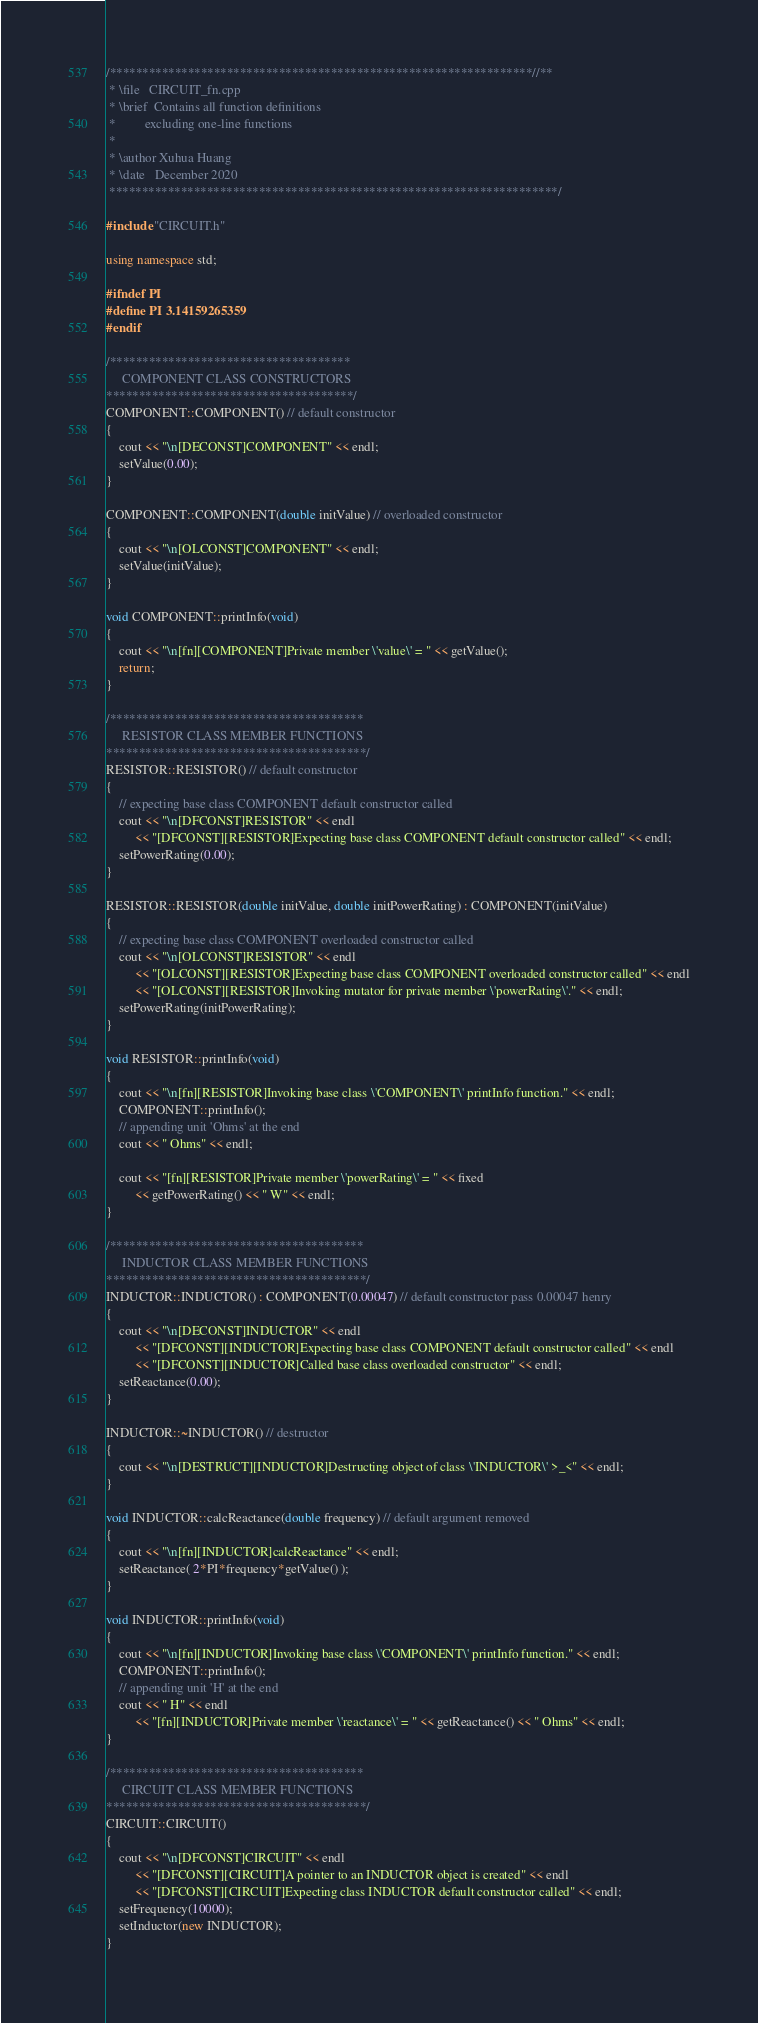<code> <loc_0><loc_0><loc_500><loc_500><_C++_>/*****************************************************************//**
 * \file   CIRCUIT_fn.cpp
 * \brief  Contains all function definitions 
 *		   excluding one-line functions
 * 
 * \author Xuhua Huang
 * \date   December 2020
 *********************************************************************/

#include "CIRCUIT.h"

using namespace std;

#ifndef PI
#define PI 3.14159265359
#endif

/*************************************
	 COMPONENT CLASS CONSTRUCTORS
**************************************/
COMPONENT::COMPONENT() // default constructor
{
	cout << "\n[DECONST]COMPONENT" << endl;
	setValue(0.00);
}

COMPONENT::COMPONENT(double initValue) // overloaded constructor
{
	cout << "\n[OLCONST]COMPONENT" << endl;
	setValue(initValue);
}

void COMPONENT::printInfo(void)
{
	cout << "\n[fn][COMPONENT]Private member \'value\' = " << getValue();
	return;
}

/***************************************
	 RESISTOR CLASS MEMBER FUNCTIONS
****************************************/
RESISTOR::RESISTOR() // default constructor
{
	// expecting base class COMPONENT default constructor called
	cout << "\n[DFCONST]RESISTOR" << endl
		 << "[DFCONST][RESISTOR]Expecting base class COMPONENT default constructor called" << endl;
	setPowerRating(0.00);
}

RESISTOR::RESISTOR(double initValue, double initPowerRating) : COMPONENT(initValue)
{
	// expecting base class COMPONENT overloaded constructor called
	cout << "\n[OLCONST]RESISTOR" << endl
		 << "[OLCONST][RESISTOR]Expecting base class COMPONENT overloaded constructor called" << endl
		 << "[OLCONST][RESISTOR]Invoking mutator for private member \'powerRating\'." << endl;
	setPowerRating(initPowerRating);
}

void RESISTOR::printInfo(void)
{
	cout << "\n[fn][RESISTOR]Invoking base class \'COMPONENT\' printInfo function." << endl;
	COMPONENT::printInfo();
	// appending unit 'Ohms' at the end
	cout << " Ohms" << endl;
	
	cout << "[fn][RESISTOR]Private member \'powerRating\' = " << fixed 
		 << getPowerRating() << " W" << endl;
}

/***************************************
	 INDUCTOR CLASS MEMBER FUNCTIONS
****************************************/
INDUCTOR::INDUCTOR() : COMPONENT(0.00047) // default constructor pass 0.00047 henry
{
	cout << "\n[DECONST]INDUCTOR" << endl
		 << "[DFCONST][INDUCTOR]Expecting base class COMPONENT default constructor called" << endl
		 << "[DFCONST][INDUCTOR]Called base class overloaded constructor" << endl;
	setReactance(0.00);
}

INDUCTOR::~INDUCTOR() // destructor
{
	cout << "\n[DESTRUCT][INDUCTOR]Destructing object of class \'INDUCTOR\' >_<" << endl;
}

void INDUCTOR::calcReactance(double frequency) // default argument removed
{
	cout << "\n[fn][INDUCTOR]calcReactance" << endl;
	setReactance( 2*PI*frequency*getValue() );
}

void INDUCTOR::printInfo(void)
{
	cout << "\n[fn][INDUCTOR]Invoking base class \'COMPONENT\' printInfo function." << endl;
	COMPONENT::printInfo();
	// appending unit 'H' at the end
	cout << " H" << endl
		 << "[fn][INDUCTOR]Private member \'reactance\' = " << getReactance() << " Ohms" << endl;
}

/***************************************
	 CIRCUIT CLASS MEMBER FUNCTIONS
****************************************/
CIRCUIT::CIRCUIT()
{
	cout << "\n[DFCONST]CIRCUIT" << endl
		 << "[DFCONST][CIRCUIT]A pointer to an INDUCTOR object is created" << endl
		 << "[DFCONST][CIRCUIT]Expecting class INDUCTOR default constructor called" << endl;
	setFrequency(10000);
	setInductor(new INDUCTOR);
}
</code> 